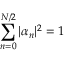<formula> <loc_0><loc_0><loc_500><loc_500>\sum _ { n = 0 } ^ { N / 2 } | \alpha _ { n } | ^ { 2 } = 1</formula> 